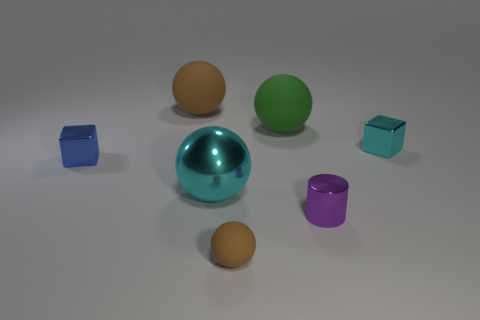There is a block left of the cyan sphere; is it the same size as the metallic sphere? No, the block to the left of the cyan sphere is not the same size as the metallic sphere. The block appears to be smaller in comparison to the metallic sphere, which has larger visible dimensions. 